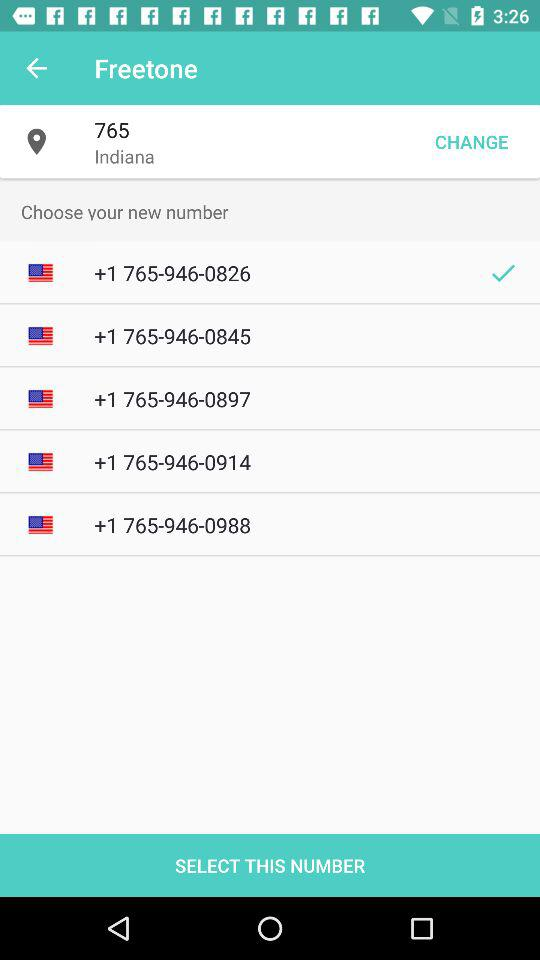How many numbers are available to choose from?
Answer the question using a single word or phrase. 5 